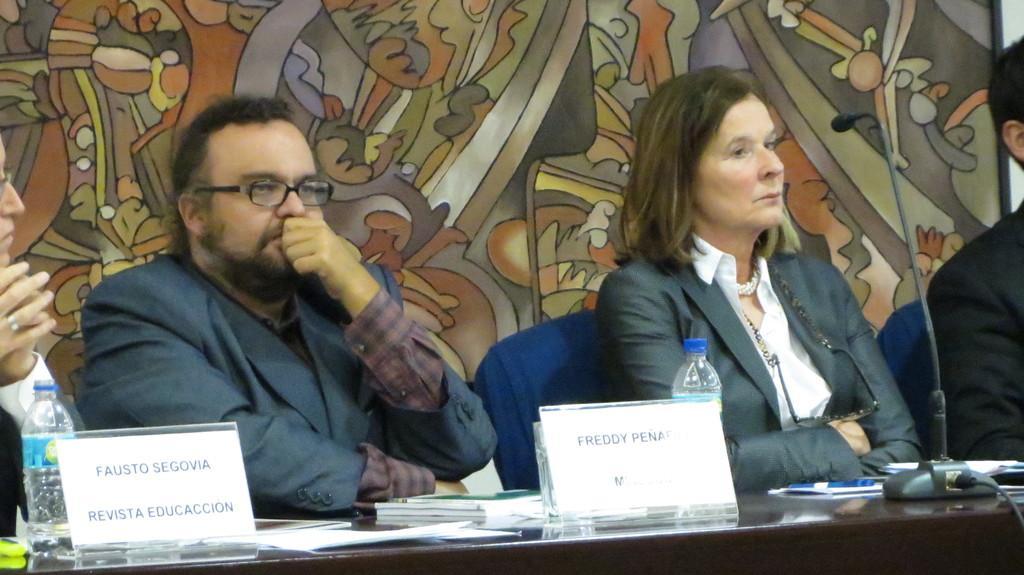How would you summarize this image in a sentence or two? These people are sitting on chairs. In-front of them there is a table, on this table there are name boards, bottles, mic, books and things. Background there is a designed wall. 